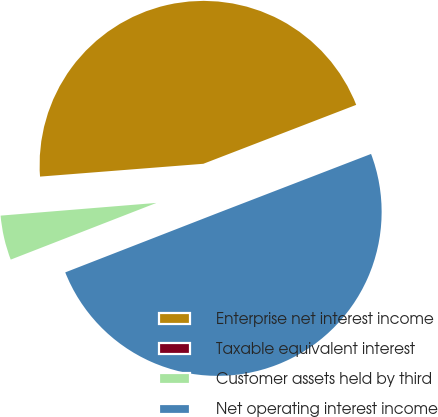<chart> <loc_0><loc_0><loc_500><loc_500><pie_chart><fcel>Enterprise net interest income<fcel>Taxable equivalent interest<fcel>Customer assets held by third<fcel>Net operating interest income<nl><fcel>45.39%<fcel>0.05%<fcel>4.61%<fcel>49.95%<nl></chart> 